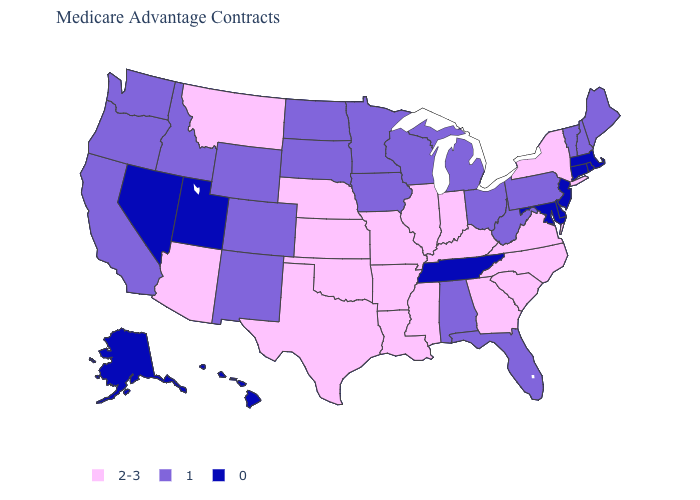Name the states that have a value in the range 2-3?
Be succinct. Arkansas, Arizona, Georgia, Illinois, Indiana, Kansas, Kentucky, Louisiana, Missouri, Mississippi, Montana, North Carolina, Nebraska, New York, Oklahoma, South Carolina, Texas, Virginia. Which states have the lowest value in the USA?
Keep it brief. Alaska, Connecticut, Delaware, Hawaii, Massachusetts, Maryland, New Jersey, Nevada, Rhode Island, Tennessee, Utah. What is the value of Alaska?
Quick response, please. 0. Name the states that have a value in the range 1?
Be succinct. Alabama, California, Colorado, Florida, Iowa, Idaho, Maine, Michigan, Minnesota, North Dakota, New Hampshire, New Mexico, Ohio, Oregon, Pennsylvania, South Dakota, Vermont, Washington, Wisconsin, West Virginia, Wyoming. What is the value of Massachusetts?
Concise answer only. 0. Name the states that have a value in the range 1?
Write a very short answer. Alabama, California, Colorado, Florida, Iowa, Idaho, Maine, Michigan, Minnesota, North Dakota, New Hampshire, New Mexico, Ohio, Oregon, Pennsylvania, South Dakota, Vermont, Washington, Wisconsin, West Virginia, Wyoming. How many symbols are there in the legend?
Quick response, please. 3. Does the first symbol in the legend represent the smallest category?
Give a very brief answer. No. How many symbols are there in the legend?
Short answer required. 3. What is the value of Washington?
Answer briefly. 1. Among the states that border Florida , which have the highest value?
Answer briefly. Georgia. Name the states that have a value in the range 0?
Answer briefly. Alaska, Connecticut, Delaware, Hawaii, Massachusetts, Maryland, New Jersey, Nevada, Rhode Island, Tennessee, Utah. Does Louisiana have the highest value in the USA?
Quick response, please. Yes. What is the highest value in the Northeast ?
Answer briefly. 2-3. 